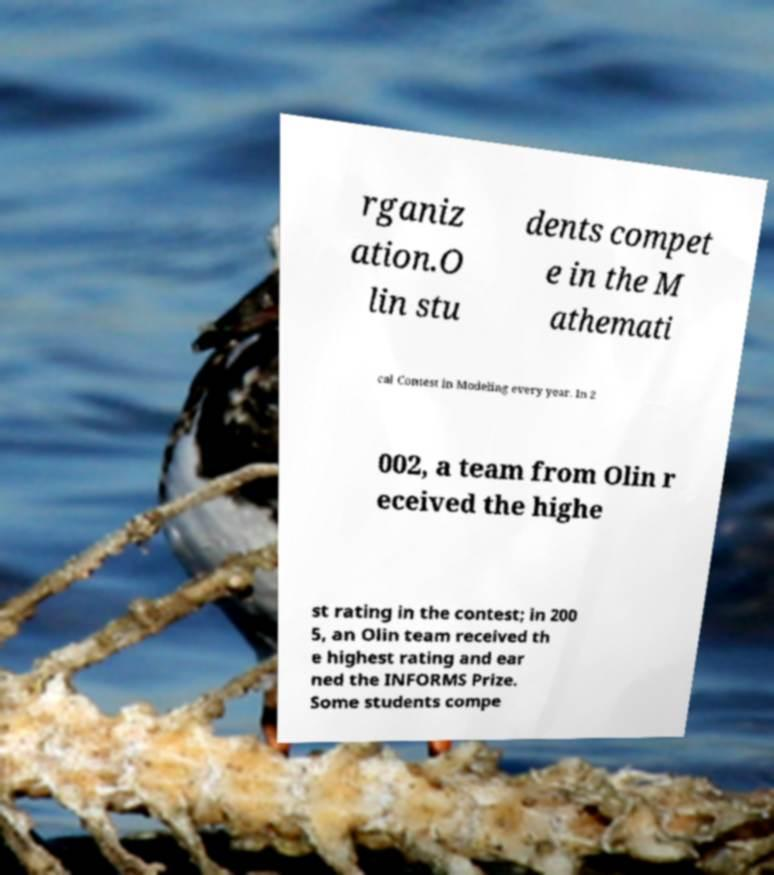There's text embedded in this image that I need extracted. Can you transcribe it verbatim? rganiz ation.O lin stu dents compet e in the M athemati cal Contest in Modeling every year. In 2 002, a team from Olin r eceived the highe st rating in the contest; in 200 5, an Olin team received th e highest rating and ear ned the INFORMS Prize. Some students compe 